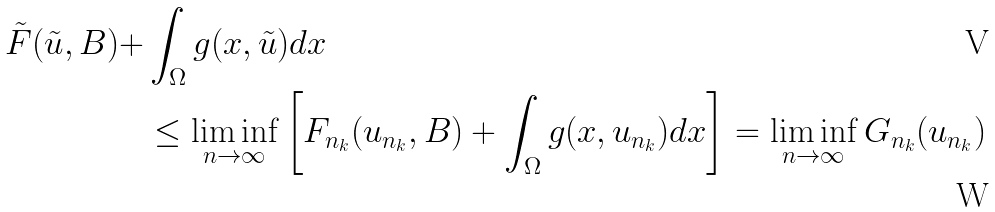Convert formula to latex. <formula><loc_0><loc_0><loc_500><loc_500>\tilde { F } ( \tilde { u } , B ) + & \int _ { \Omega } g ( x , \tilde { u } ) d x \\ & \leq \liminf _ { n \rightarrow \infty } \left [ F _ { n _ { k } } ( u _ { n _ { k } } , B ) + \int _ { \Omega } g ( x , u _ { n _ { k } } ) d x \right ] = \liminf _ { n \rightarrow \infty } G _ { n _ { k } } ( u _ { n _ { k } } )</formula> 